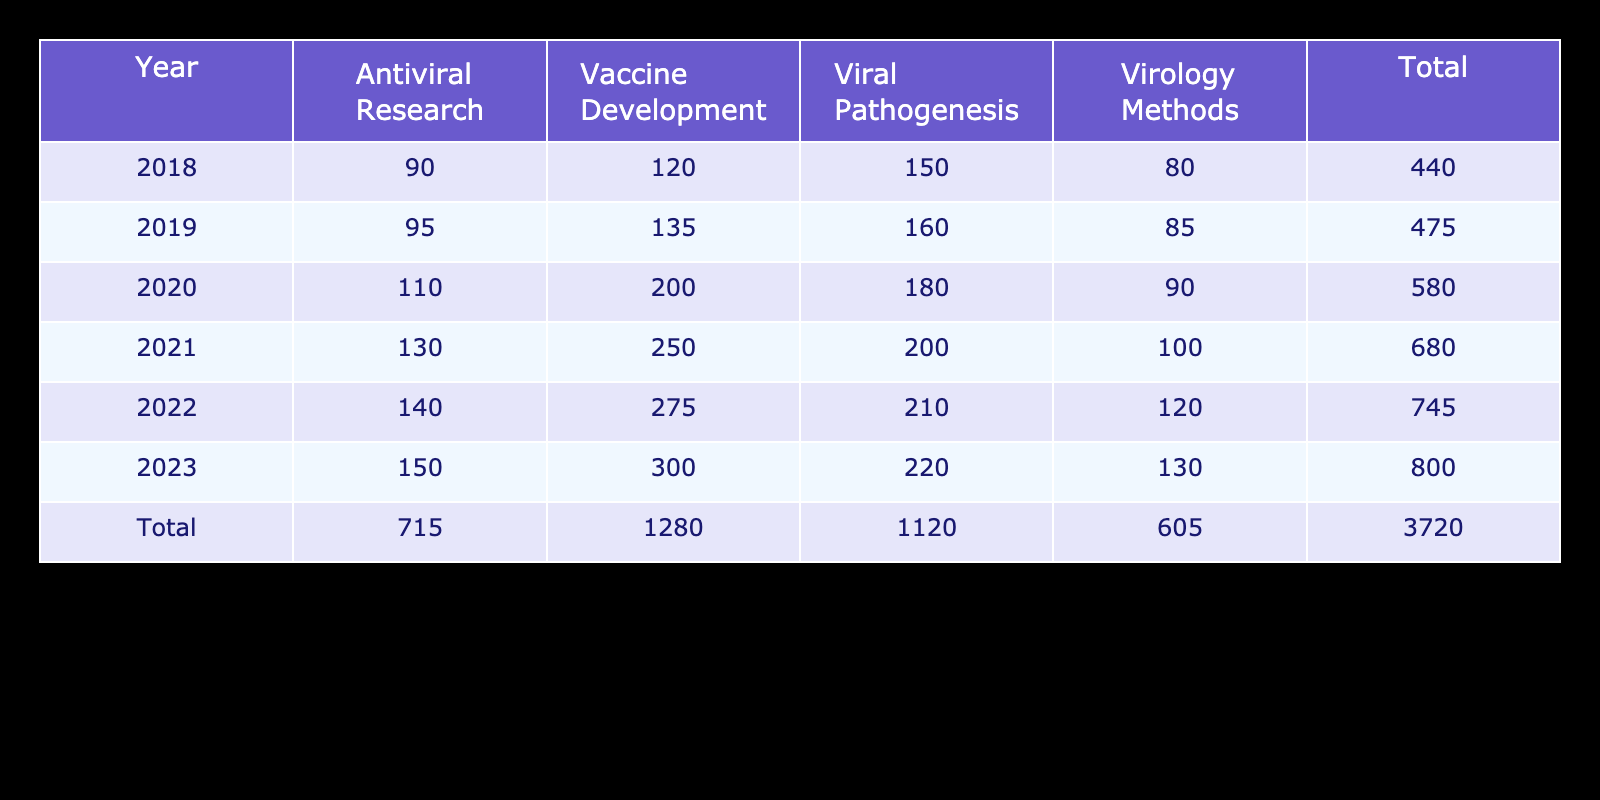What was the total number of publications in Vaccine Development in 2021? The table shows that in 2021, there were 250 publications in the Vaccine Development subfield. So the total is 250.
Answer: 250 What was the average number of publications in Viral Pathogenesis across the years 2019 to 2022? The number of publications in Viral Pathogenesis for the years 2019 to 2022 are 160, 180, 200, and 210. Adding them gives 160 + 180 + 200 + 210 = 750. Since there are 4 years, the average is 750/4 = 187.5.
Answer: 187.5 Did the number of publications in Virology Methods increase from 2018 to 2023? In 2018, there were 80 publications in Virology Methods, and in 2023, there were 130. Since 130 is greater than 80, it indicates an increase.
Answer: Yes What was the total number of publications across all subfields in 2020? The number of publications in 2020 are: Viral Pathogenesis (180), Vaccine Development (200), Virology Methods (90), and Antiviral Research (110). Summing these values gives 180 + 200 + 90 + 110 = 580. Therefore, the total number of publications in 2020 is 580.
Answer: 580 In which year did Vaccine Development have its highest publication count, and what was that count? The table indicates that Vaccine Development had 300 publications in the year 2023, which is higher than in previous years (275 in 2022, 250 in 2021, etc.). Hence, the highest publication count was in 2023 with 300.
Answer: 2023, 300 What is the difference in the number of Antiviral Research publications between 2018 and 2023? The number of publications in Antiviral Research for 2018 was 90, and for 2023, it was 150. To find the difference, subtract 90 from 150, which equals 60.
Answer: 60 Which subfield had the lowest number of publications in 2019? Reviewing the numbers for 2019, we have: Viral Pathogenesis (160), Vaccine Development (135), Virology Methods (85), and Antiviral Research (95). The lowest among them is 85 from Virology Methods.
Answer: Virology Methods What is the total change in the number of publications for Vaccine Development from 2018 to 2023? The count for Vaccine Development in 2018 was 120, and in 2023 it rose to 300. To calculate the change, subtract 120 from 300, resulting in an increase of 180.
Answer: 180 